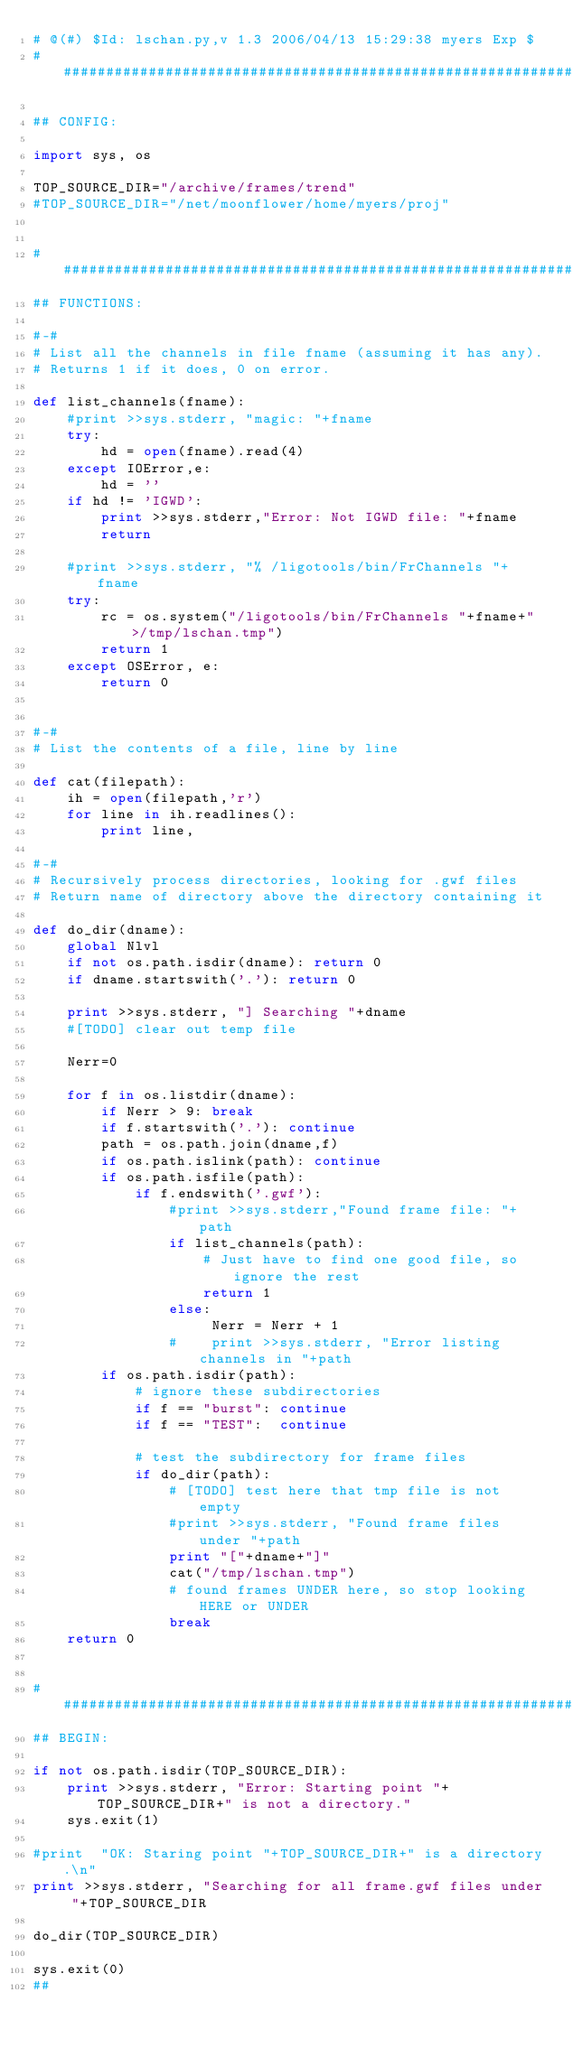Convert code to text. <code><loc_0><loc_0><loc_500><loc_500><_Python_># @(#) $Id: lschan.py,v 1.3 2006/04/13 15:29:38 myers Exp $
########################################################################

## CONFIG:

import sys, os

TOP_SOURCE_DIR="/archive/frames/trend"
#TOP_SOURCE_DIR="/net/moonflower/home/myers/proj"


########################################################################
## FUNCTIONS:

#-#
# List all the channels in file fname (assuming it has any).
# Returns 1 if it does, 0 on error.

def list_channels(fname):
    #print >>sys.stderr, "magic: "+fname
    try:
        hd = open(fname).read(4)
    except IOError,e:
        hd = ''
    if hd != 'IGWD':
        print >>sys.stderr,"Error: Not IGWD file: "+fname
        return

    #print >>sys.stderr, "% /ligotools/bin/FrChannels "+fname
    try:
        rc = os.system("/ligotools/bin/FrChannels "+fname+" >/tmp/lschan.tmp")
        return 1
    except OSError, e:
        return 0


#-#
# List the contents of a file, line by line

def cat(filepath):
    ih = open(filepath,'r')
    for line in ih.readlines():
        print line,

#-#
# Recursively process directories, looking for .gwf files
# Return name of directory above the directory containing it

def do_dir(dname):
    global Nlvl
    if not os.path.isdir(dname): return 0
    if dname.startswith('.'): return 0

    print >>sys.stderr, "] Searching "+dname
    #[TODO] clear out temp file
    
    Nerr=0

    for f in os.listdir(dname):
        if Nerr > 9: break
        if f.startswith('.'): continue
        path = os.path.join(dname,f)
        if os.path.islink(path): continue
        if os.path.isfile(path):
            if f.endswith('.gwf'):
                #print >>sys.stderr,"Found frame file: "+path
                if list_channels(path): 
                    # Just have to find one good file, so ignore the rest
                    return 1
                else:
                     Nerr = Nerr + 1
                #    print >>sys.stderr, "Error listing channels in "+path
        if os.path.isdir(path):  
            # ignore these subdirectories    
            if f == "burst": continue
            if f == "TEST":  continue    

            # test the subdirectory for frame files
            if do_dir(path):
                # [TODO] test here that tmp file is not empty
                #print >>sys.stderr, "Found frame files under "+path
                print "["+dname+"]"
                cat("/tmp/lschan.tmp")
                # found frames UNDER here, so stop looking HERE or UNDER
                break  
    return 0
        

########################################################################
## BEGIN:

if not os.path.isdir(TOP_SOURCE_DIR):
    print >>sys.stderr, "Error: Starting point "+TOP_SOURCE_DIR+" is not a directory."
    sys.exit(1)

#print  "OK: Staring point "+TOP_SOURCE_DIR+" is a directory.\n"
print >>sys.stderr, "Searching for all frame.gwf files under "+TOP_SOURCE_DIR

do_dir(TOP_SOURCE_DIR)

sys.exit(0)
##
</code> 